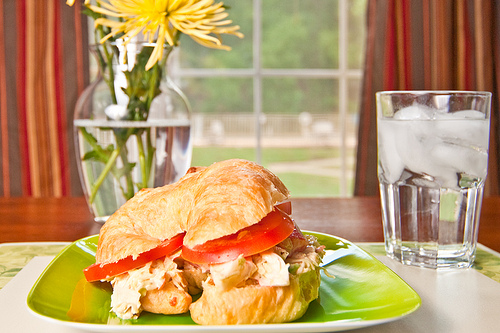Which kind of meat is on the sandwich? The sandwich contains chicken as the meat. 